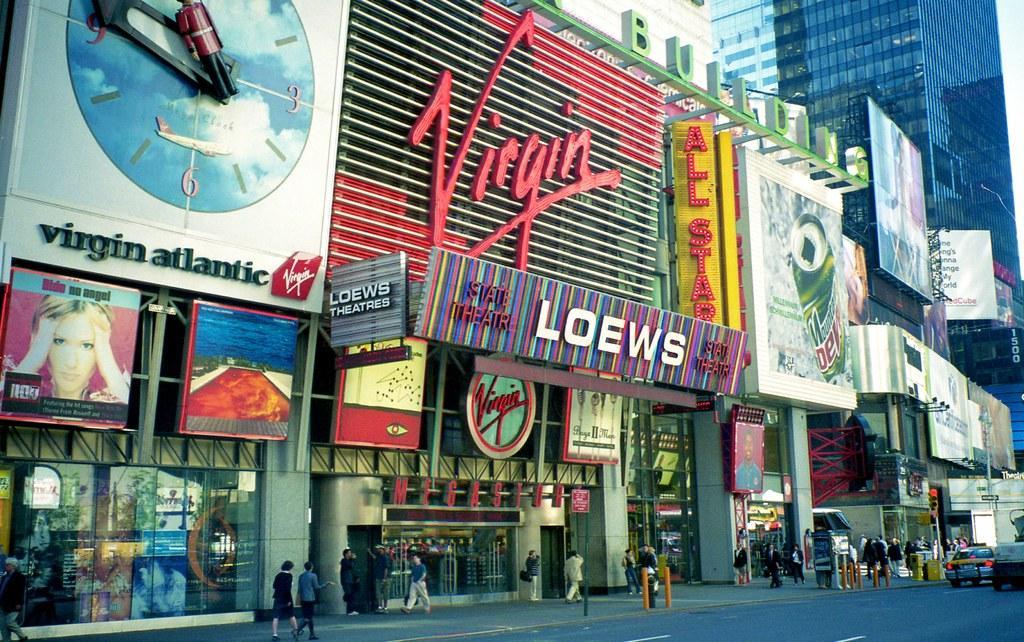How would you summarize this image in a sentence or two? In this picture we can see a group of people walking on a foot path, cars on the road, banners and in the background we can see buildings. 